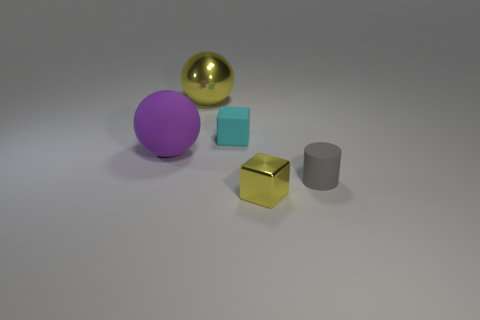Is the material of the tiny gray cylinder on the right side of the large yellow ball the same as the purple thing?
Provide a short and direct response. Yes. There is another object that is the same shape as the purple matte thing; what is its material?
Offer a very short reply. Metal. There is a ball that is the same color as the tiny metal block; what is it made of?
Your answer should be compact. Metal. Is the number of tiny yellow shiny blocks less than the number of small brown metallic objects?
Your answer should be very brief. No. There is a large sphere to the right of the big matte object; is its color the same as the small matte cylinder?
Provide a short and direct response. No. What color is the sphere that is made of the same material as the small gray cylinder?
Your answer should be compact. Purple. Does the cyan rubber cube have the same size as the purple thing?
Keep it short and to the point. No. What is the cylinder made of?
Provide a short and direct response. Rubber. There is another purple ball that is the same size as the shiny sphere; what is its material?
Offer a terse response. Rubber. Is there another cyan rubber object that has the same size as the cyan object?
Provide a short and direct response. No. 